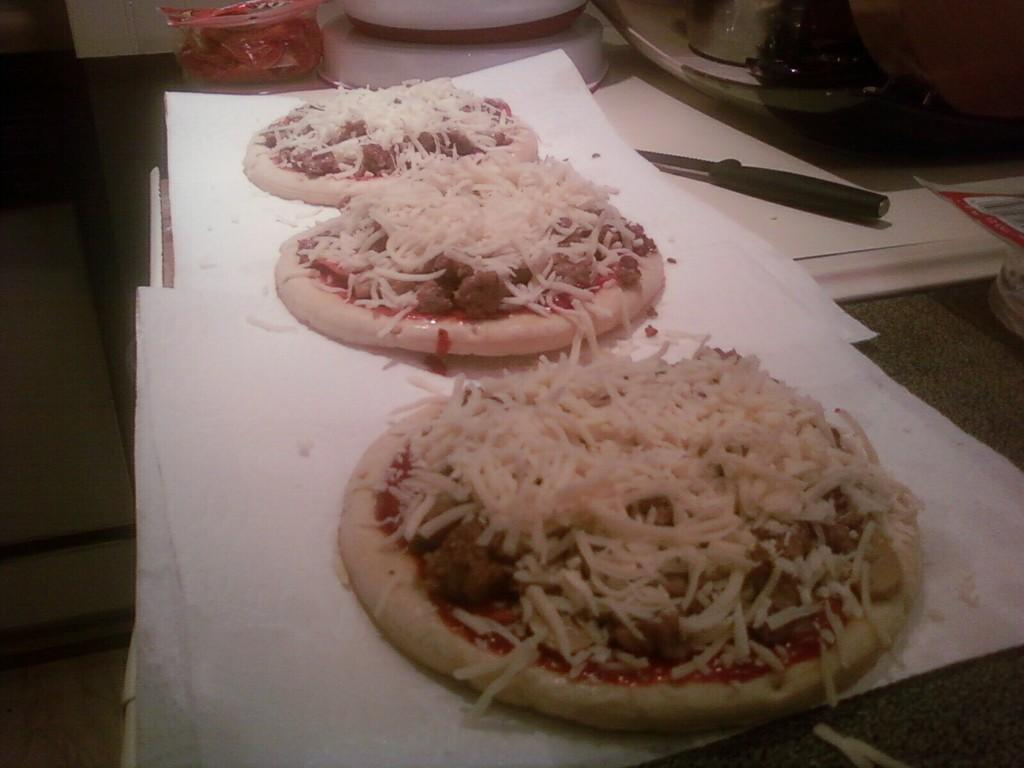What is the main piece of furniture in the image? There is a table in the image. What type of food is on the table? There are pizzas on the table. How are the pizzas arranged on the table? The pizzas are kept on a paper sheet. What utensil is present on the table? There is a knife on the table. What type of flower is on the pizza in the image? There are no flowers present on the pizzas in the image; they are made of dough, sauce, and toppings. 